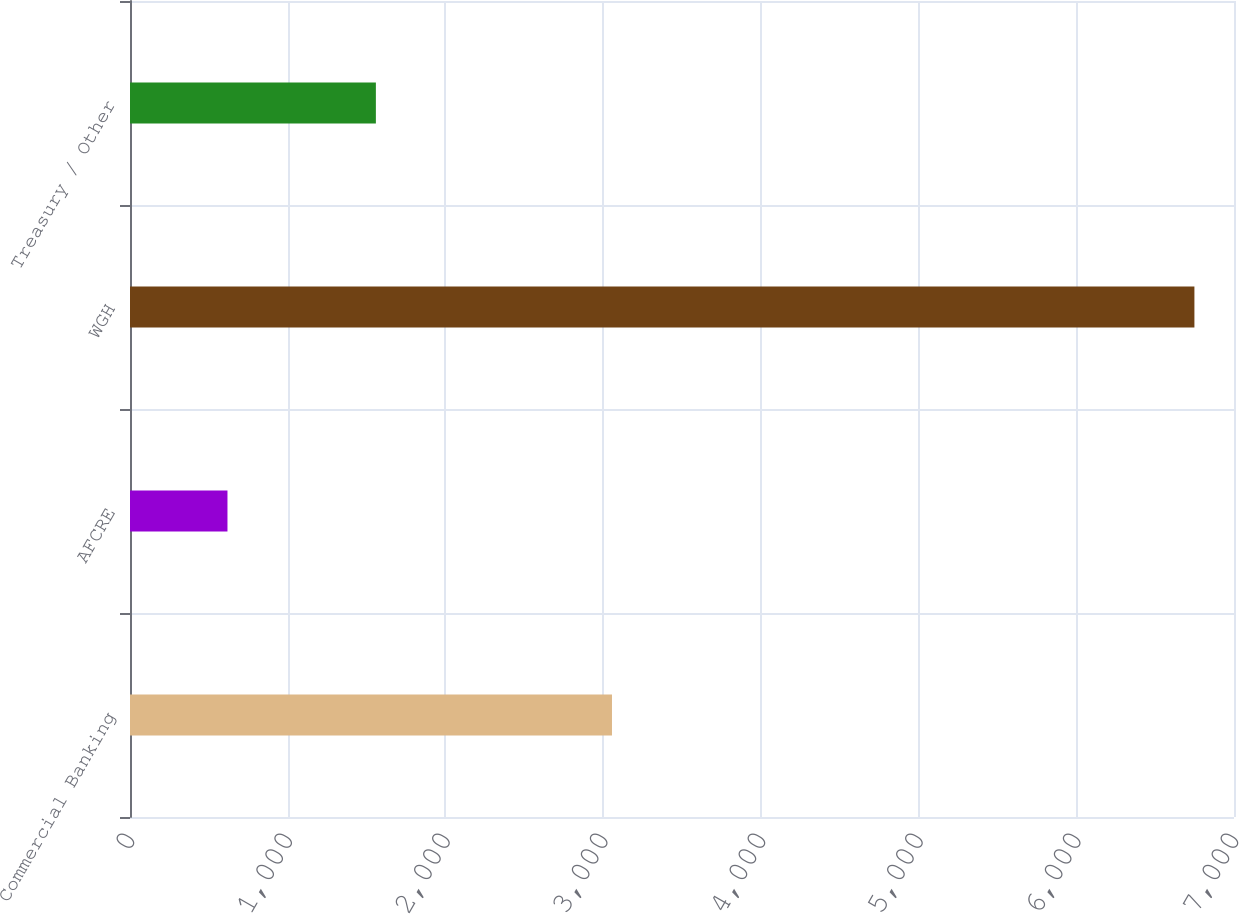<chart> <loc_0><loc_0><loc_500><loc_500><bar_chart><fcel>Commercial Banking<fcel>AFCRE<fcel>WGH<fcel>Treasury / Other<nl><fcel>3056<fcel>618<fcel>6749<fcel>1559<nl></chart> 